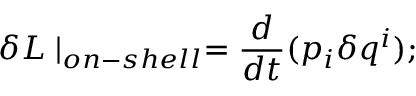<formula> <loc_0><loc_0><loc_500><loc_500>\delta L | _ { o n - s h e l l } = \frac { d } { d t } ( p _ { i } \delta q ^ { i } ) ;</formula> 